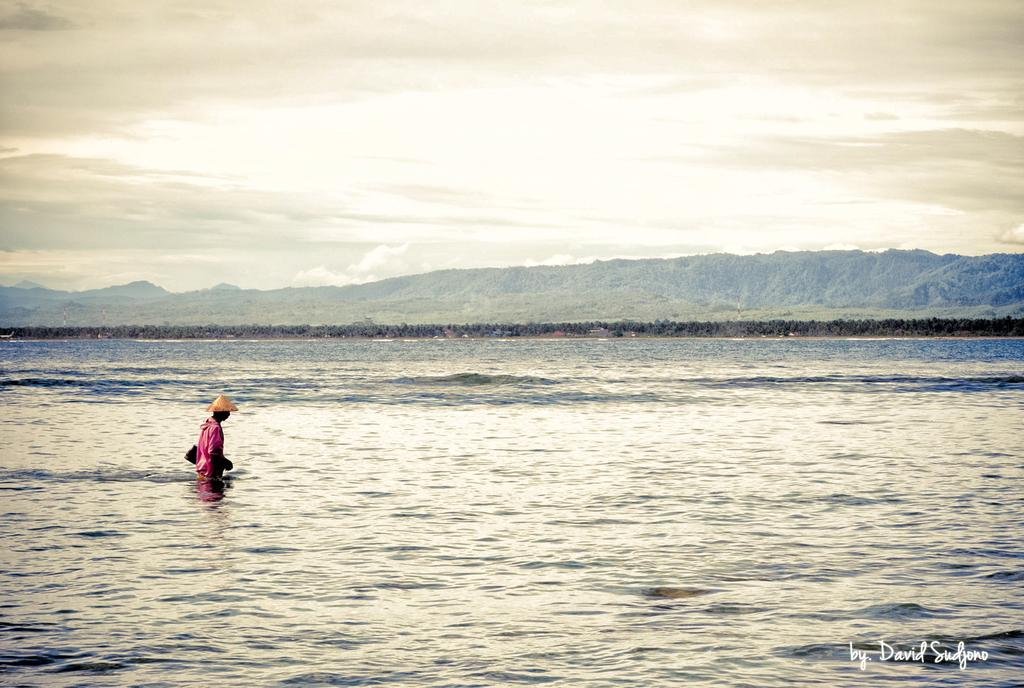What is the person in the image doing? The person is in the water. What can be seen in the background of the image? There are trees visible in the image, and there is a hill in the background. What is the condition of the sky in the image? Clouds are present in the sky. Where is the faucet located in the image? There is no faucet present in the image. What type of crook can be seen interacting with the person in the water? There is no crook present in the image; only the person in the water and the surrounding environment are visible. 